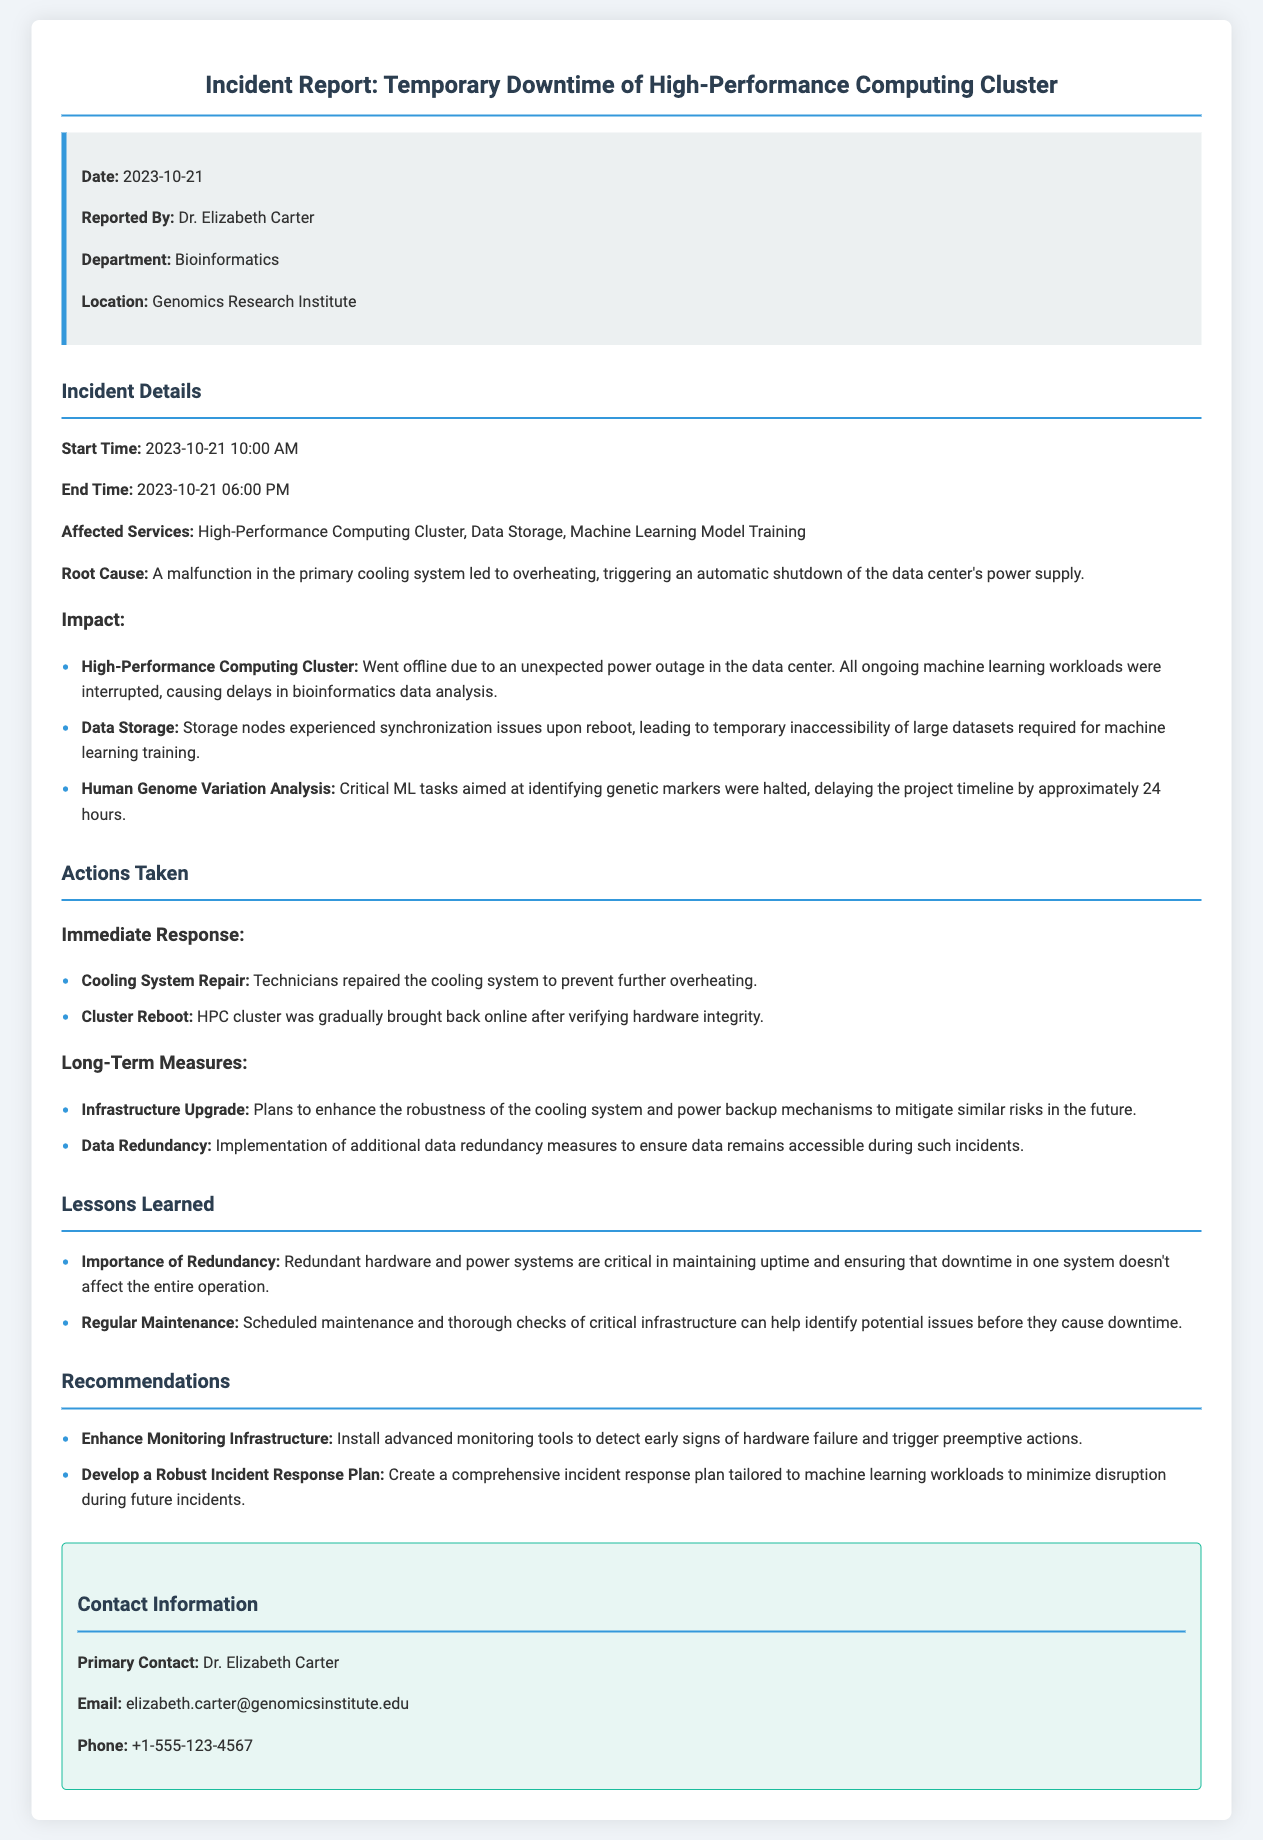What was the date of the incident? The date of the incident is explicitly stated at the beginning of the incident report.
Answer: 2023-10-21 Who reported the incident? The name of the individual who reported the incident is provided in the incident summary section.
Answer: Dr. Elizabeth Carter What was the root cause of the incident? The document details the cause of the downtime, which is found under the incident details section.
Answer: A malfunction in the primary cooling system What services were affected? The affected services are listed in the incident details section, outlining what was impacted due to the downtime.
Answer: High-Performance Computing Cluster, Data Storage, Machine Learning Model Training How long did the downtime last? The start and end times of the incident allow for the calculation of the duration of the downtime.
Answer: 8 hours What immediate action was taken regarding the cooling system? The immediate response section specifies what action was taken in response to the incident.
Answer: Technicians repaired the cooling system What long-term measure is suggested in the report? The long-term measures are detailed in the actions taken section, focusing on improvements to infrastructure.
Answer: Plans to enhance the robustness of the cooling system What is one lesson learned from the incident? Several lessons are identified in the lessons learned section, highlighting important takeaways.
Answer: Importance of Redundancy What is the primary contact's email? The contact information section provides the email for the primary contact regarding the incident.
Answer: elizabeth.carter@genomicsinstitute.edu 